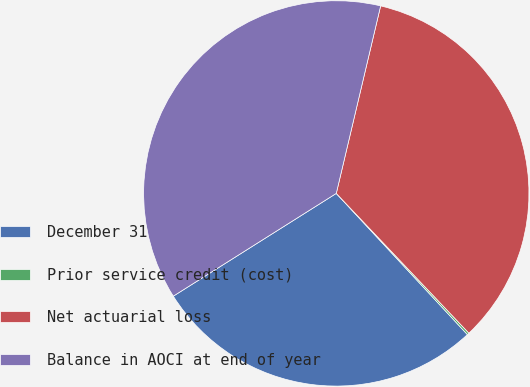Convert chart. <chart><loc_0><loc_0><loc_500><loc_500><pie_chart><fcel>December 31<fcel>Prior service credit (cost)<fcel>Net actuarial loss<fcel>Balance in AOCI at end of year<nl><fcel>27.96%<fcel>0.17%<fcel>34.22%<fcel>37.65%<nl></chart> 